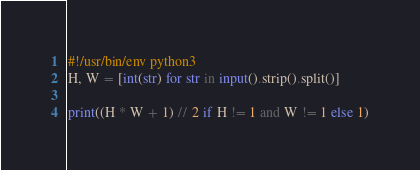<code> <loc_0><loc_0><loc_500><loc_500><_Python_>#!/usr/bin/env python3
H, W = [int(str) for str in input().strip().split()]

print((H * W + 1) // 2 if H != 1 and W != 1 else 1)</code> 